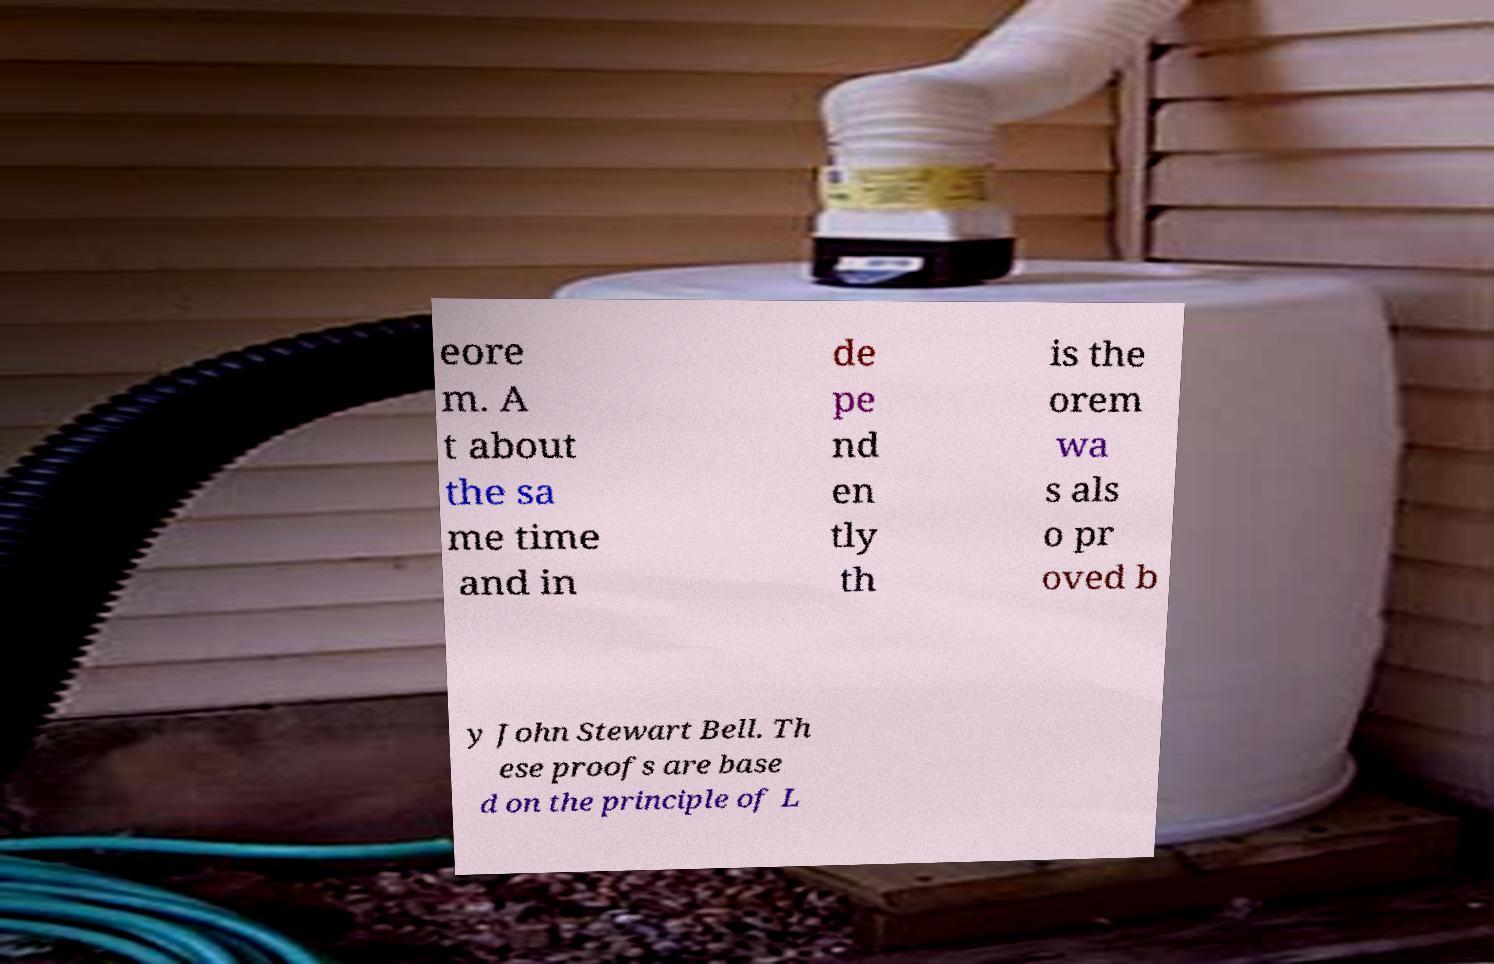Could you extract and type out the text from this image? eore m. A t about the sa me time and in de pe nd en tly th is the orem wa s als o pr oved b y John Stewart Bell. Th ese proofs are base d on the principle of L 